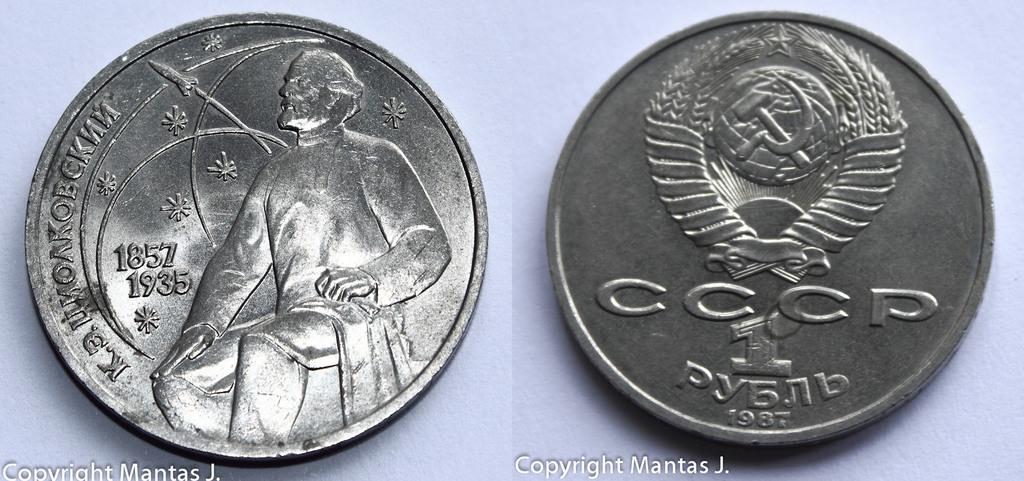What is the date on the coin on the right?
Give a very brief answer. 1987. What is the date on the coin to the left?
Offer a terse response. 1857. 